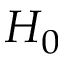<formula> <loc_0><loc_0><loc_500><loc_500>H _ { 0 }</formula> 